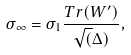Convert formula to latex. <formula><loc_0><loc_0><loc_500><loc_500>\sigma _ { \infty } = \sigma _ { 1 } \frac { T r ( W ^ { \prime } ) } { \sqrt { ( } \Delta ) } ,</formula> 